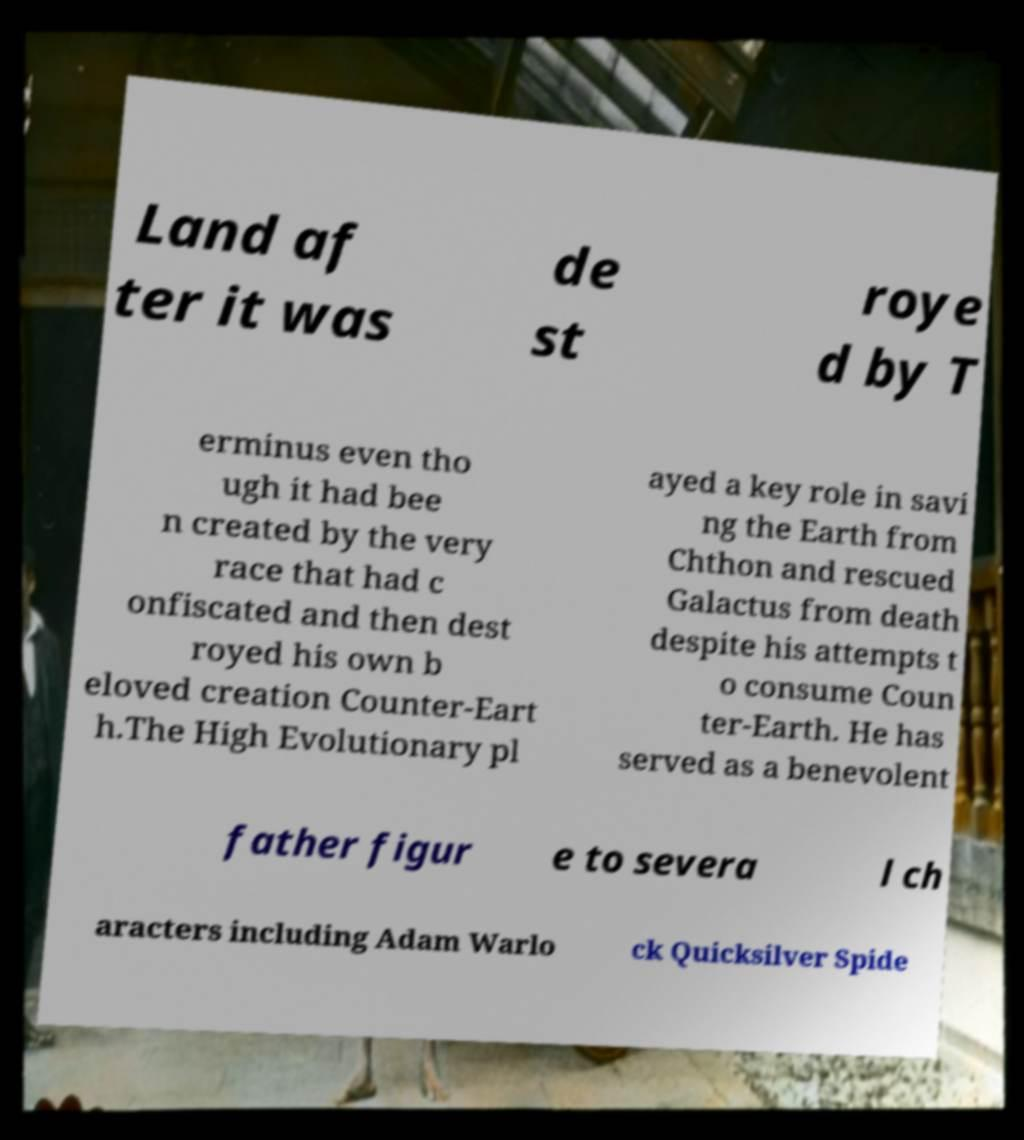Can you read and provide the text displayed in the image?This photo seems to have some interesting text. Can you extract and type it out for me? Land af ter it was de st roye d by T erminus even tho ugh it had bee n created by the very race that had c onfiscated and then dest royed his own b eloved creation Counter-Eart h.The High Evolutionary pl ayed a key role in savi ng the Earth from Chthon and rescued Galactus from death despite his attempts t o consume Coun ter-Earth. He has served as a benevolent father figur e to severa l ch aracters including Adam Warlo ck Quicksilver Spide 